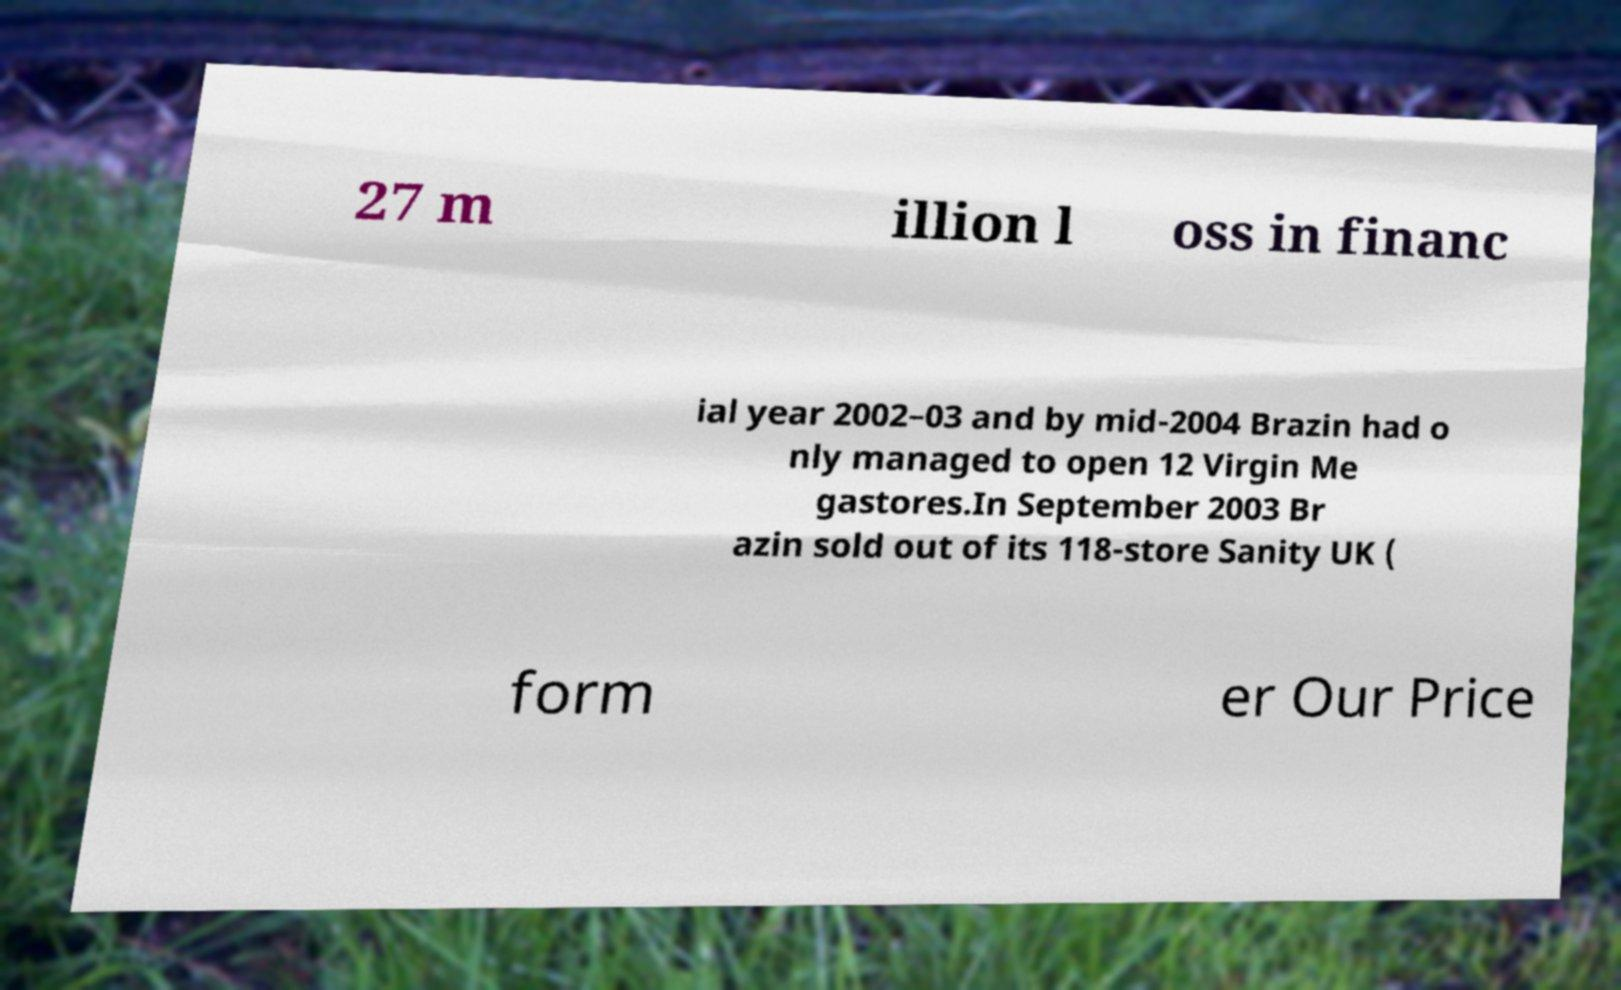Could you extract and type out the text from this image? 27 m illion l oss in financ ial year 2002–03 and by mid-2004 Brazin had o nly managed to open 12 Virgin Me gastores.In September 2003 Br azin sold out of its 118-store Sanity UK ( form er Our Price 